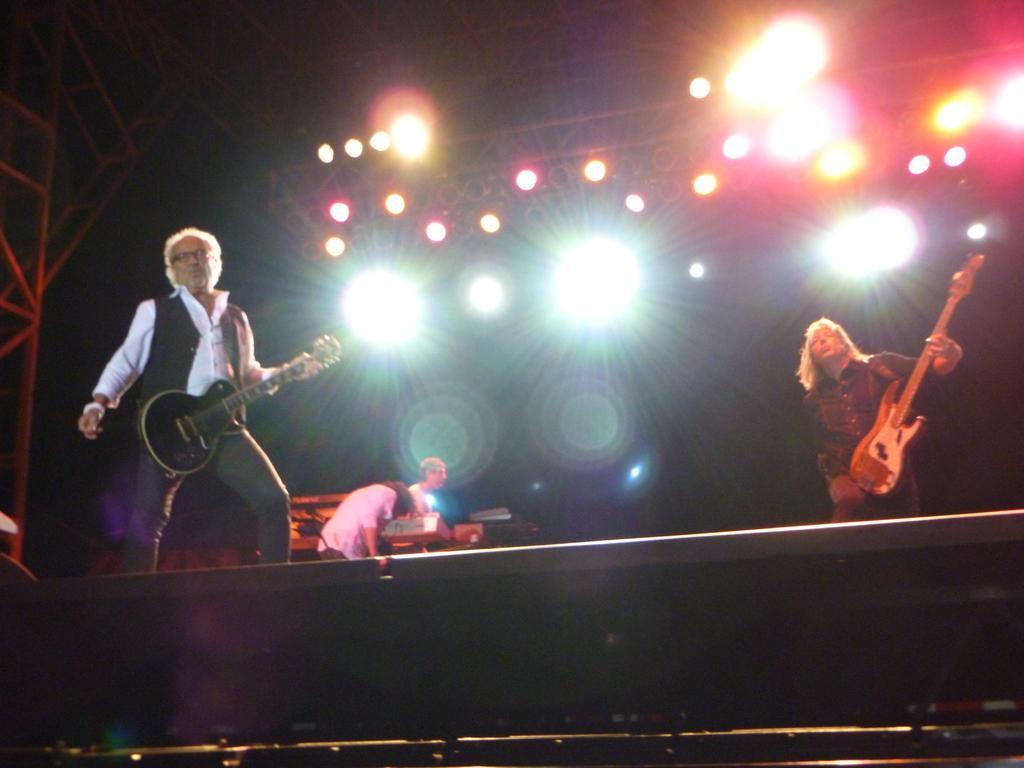Could you give a brief overview of what you see in this image? In the image there are two men playing guitar and in the background another man using other musical instrument. On the stage there are many colorful lights and remaining all its dark. 